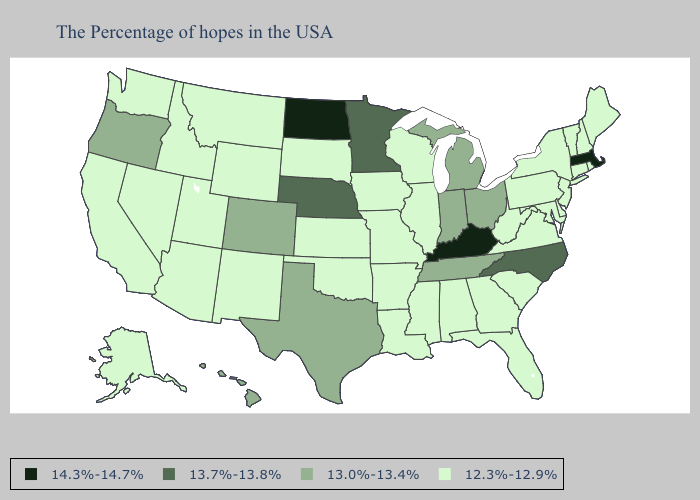Among the states that border Montana , which have the lowest value?
Write a very short answer. South Dakota, Wyoming, Idaho. What is the lowest value in states that border Montana?
Keep it brief. 12.3%-12.9%. Does Delaware have the same value as Indiana?
Concise answer only. No. What is the value of New Hampshire?
Answer briefly. 12.3%-12.9%. Does North Dakota have the highest value in the USA?
Write a very short answer. Yes. What is the lowest value in the West?
Quick response, please. 12.3%-12.9%. What is the lowest value in the Northeast?
Give a very brief answer. 12.3%-12.9%. What is the value of South Carolina?
Write a very short answer. 12.3%-12.9%. Does Nebraska have the lowest value in the USA?
Keep it brief. No. Name the states that have a value in the range 13.7%-13.8%?
Be succinct. North Carolina, Minnesota, Nebraska. What is the lowest value in the USA?
Answer briefly. 12.3%-12.9%. Does Missouri have a lower value than Rhode Island?
Keep it brief. No. How many symbols are there in the legend?
Write a very short answer. 4. What is the value of Arizona?
Keep it brief. 12.3%-12.9%. Name the states that have a value in the range 13.7%-13.8%?
Keep it brief. North Carolina, Minnesota, Nebraska. 